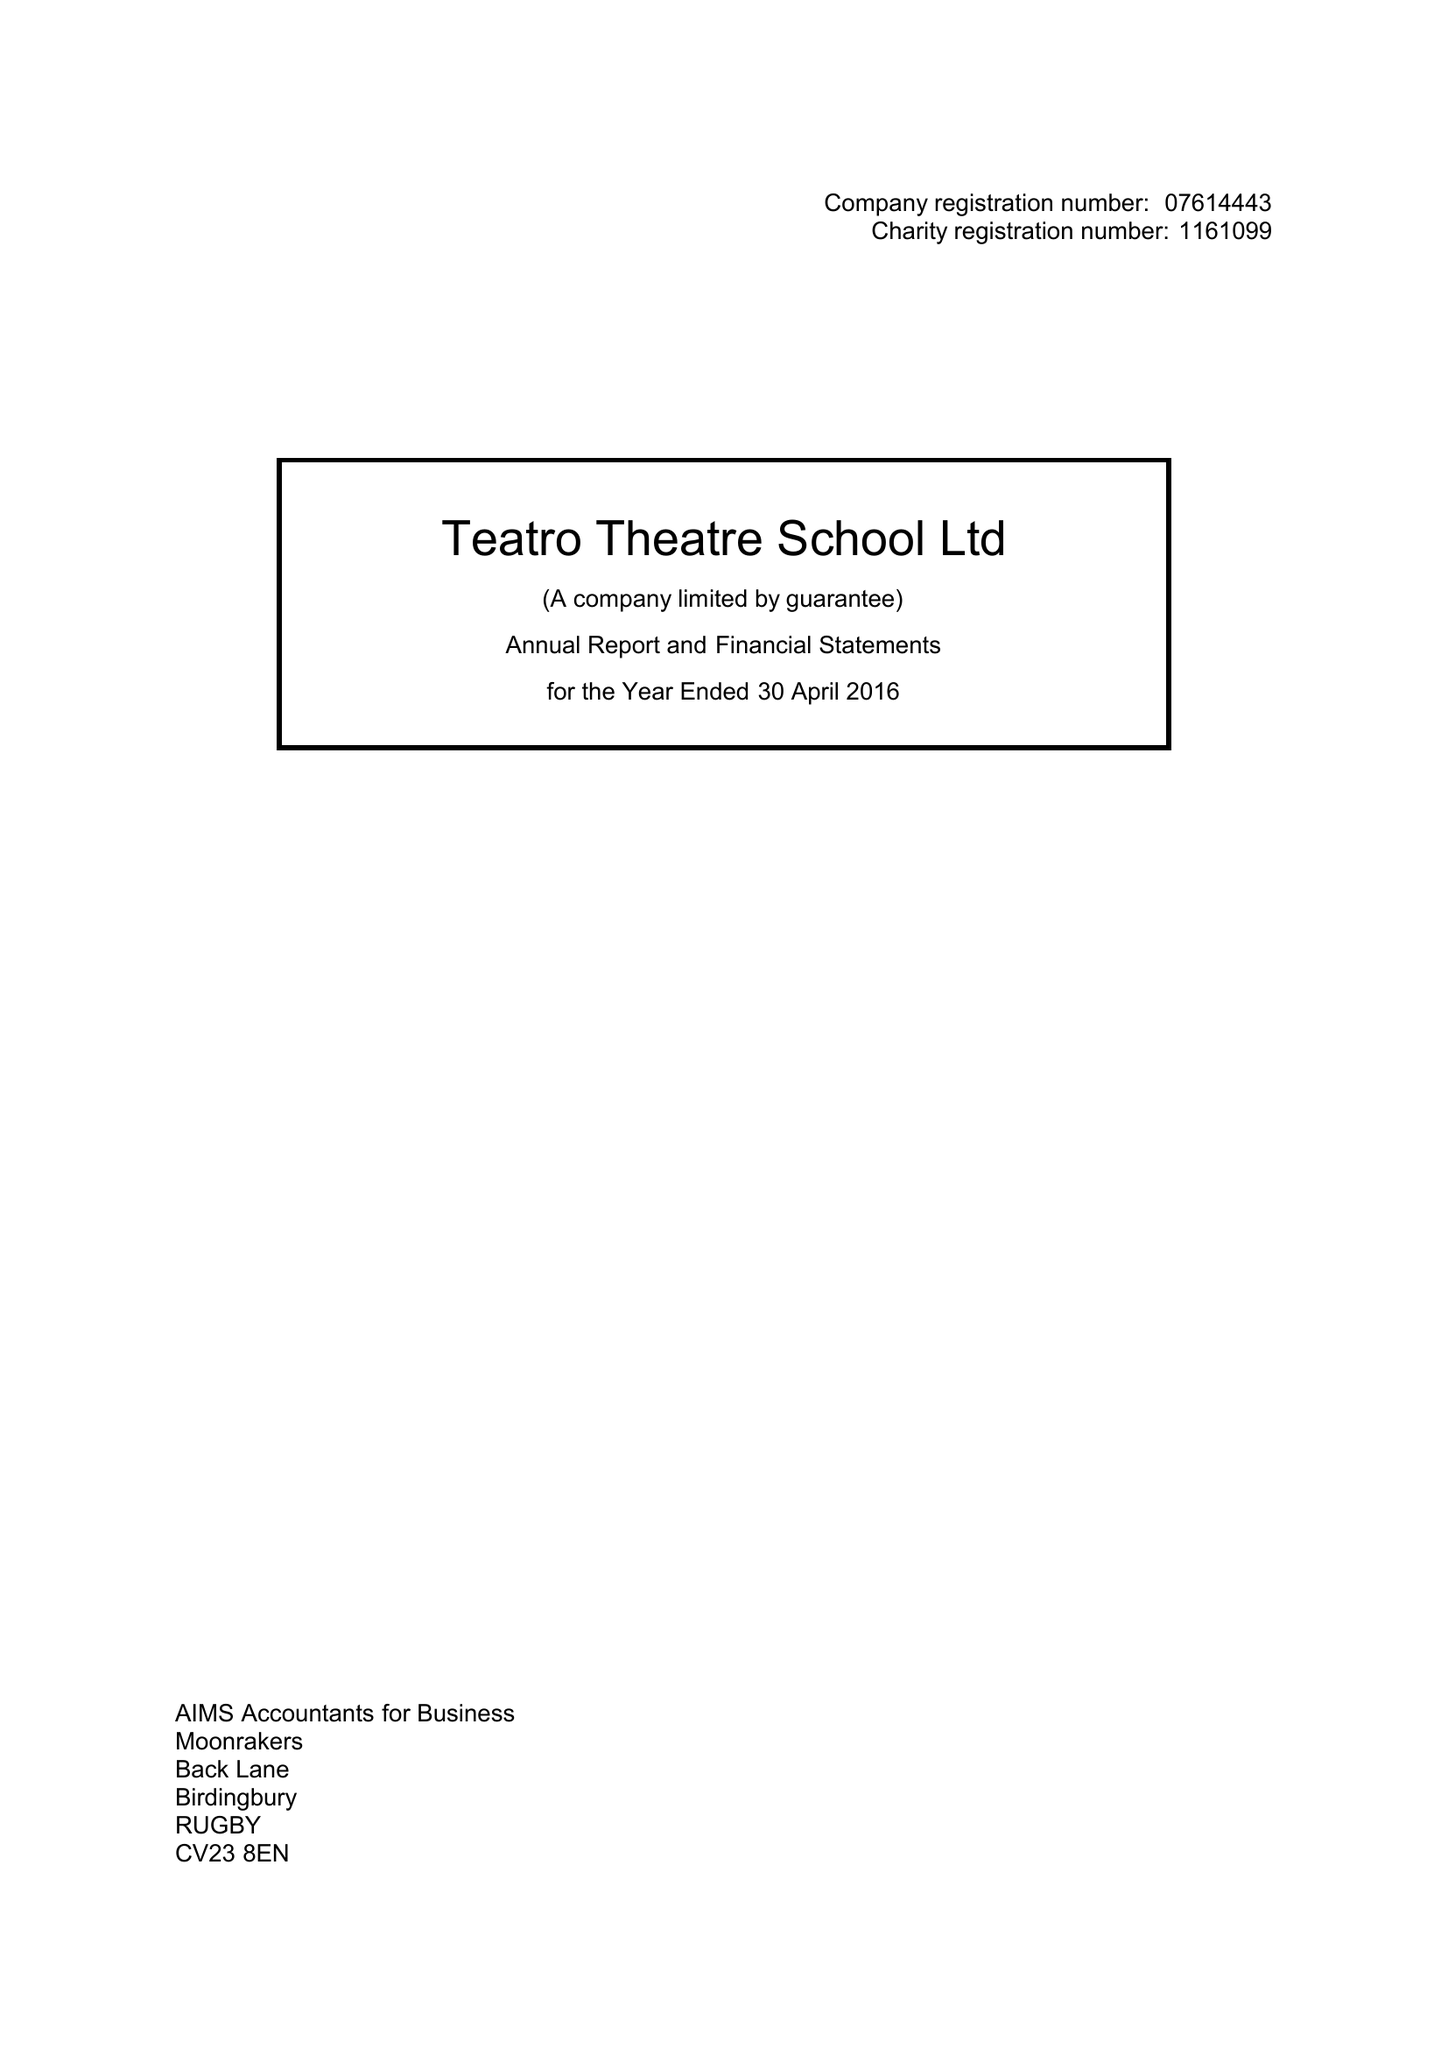What is the value for the address__postcode?
Answer the question using a single word or phrase. CV32 5AG 